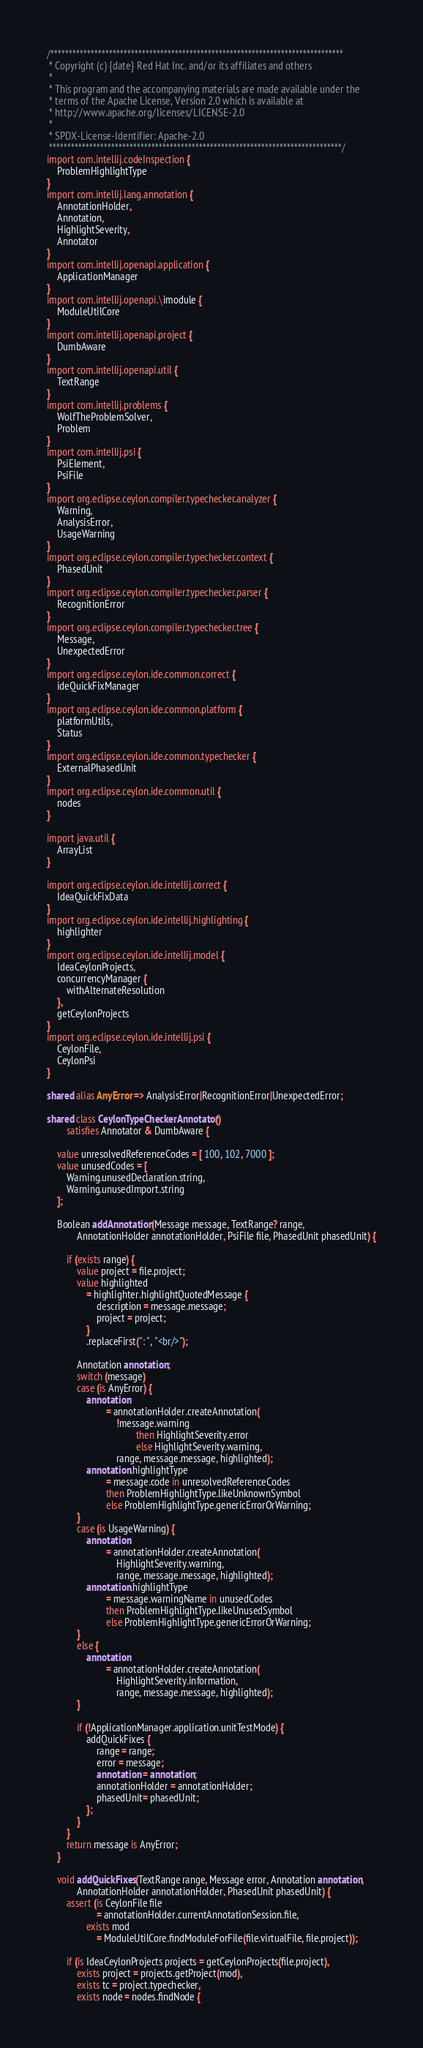Convert code to text. <code><loc_0><loc_0><loc_500><loc_500><_Ceylon_>/********************************************************************************
 * Copyright (c) {date} Red Hat Inc. and/or its affiliates and others
 *
 * This program and the accompanying materials are made available under the 
 * terms of the Apache License, Version 2.0 which is available at
 * http://www.apache.org/licenses/LICENSE-2.0
 *
 * SPDX-License-Identifier: Apache-2.0 
 ********************************************************************************/
import com.intellij.codeInspection {
    ProblemHighlightType
}
import com.intellij.lang.annotation {
    AnnotationHolder,
    Annotation,
    HighlightSeverity,
    Annotator
}
import com.intellij.openapi.application {
    ApplicationManager
}
import com.intellij.openapi.\imodule {
    ModuleUtilCore
}
import com.intellij.openapi.project {
    DumbAware
}
import com.intellij.openapi.util {
    TextRange
}
import com.intellij.problems {
    WolfTheProblemSolver,
    Problem
}
import com.intellij.psi {
    PsiElement,
    PsiFile
}
import org.eclipse.ceylon.compiler.typechecker.analyzer {
    Warning,
    AnalysisError,
    UsageWarning
}
import org.eclipse.ceylon.compiler.typechecker.context {
    PhasedUnit
}
import org.eclipse.ceylon.compiler.typechecker.parser {
    RecognitionError
}
import org.eclipse.ceylon.compiler.typechecker.tree {
    Message,
    UnexpectedError
}
import org.eclipse.ceylon.ide.common.correct {
    ideQuickFixManager
}
import org.eclipse.ceylon.ide.common.platform {
    platformUtils,
    Status
}
import org.eclipse.ceylon.ide.common.typechecker {
    ExternalPhasedUnit
}
import org.eclipse.ceylon.ide.common.util {
    nodes
}

import java.util {
    ArrayList
}

import org.eclipse.ceylon.ide.intellij.correct {
    IdeaQuickFixData
}
import org.eclipse.ceylon.ide.intellij.highlighting {
    highlighter
}
import org.eclipse.ceylon.ide.intellij.model {
    IdeaCeylonProjects,
    concurrencyManager {
        withAlternateResolution
    },
    getCeylonProjects
}
import org.eclipse.ceylon.ide.intellij.psi {
    CeylonFile,
    CeylonPsi
}

shared alias AnyError => AnalysisError|RecognitionError|UnexpectedError;

shared class CeylonTypeCheckerAnnotator() 
        satisfies Annotator & DumbAware {

    value unresolvedReferenceCodes = [ 100, 102, 7000 ];
    value unusedCodes = [
        Warning.unusedDeclaration.string,
        Warning.unusedImport.string
    ];

    Boolean addAnnotation(Message message, TextRange? range,
            AnnotationHolder annotationHolder, PsiFile file, PhasedUnit phasedUnit) {

        if (exists range) {
            value project = file.project;
            value highlighted
                = highlighter.highlightQuotedMessage {
                    description = message.message;
                    project = project;
                }
                .replaceFirst(": ", "<br/>");

            Annotation annotation;
            switch (message)
            case (is AnyError) {
                annotation
                        = annotationHolder.createAnnotation(
                            !message.warning
                                    then HighlightSeverity.error
                                    else HighlightSeverity.warning,
                            range, message.message, highlighted);
                annotation.highlightType
                        = message.code in unresolvedReferenceCodes
                        then ProblemHighlightType.likeUnknownSymbol
                        else ProblemHighlightType.genericErrorOrWarning;
            }
            case (is UsageWarning) {
                annotation
                        = annotationHolder.createAnnotation(
                            HighlightSeverity.warning,
                            range, message.message, highlighted);
                annotation.highlightType
                        = message.warningName in unusedCodes
                        then ProblemHighlightType.likeUnusedSymbol
                        else ProblemHighlightType.genericErrorOrWarning;
            }
            else {
                annotation
                        = annotationHolder.createAnnotation(
                            HighlightSeverity.information,
                            range, message.message, highlighted);
            }

            if (!ApplicationManager.application.unitTestMode) {
                addQuickFixes {
                    range = range;
                    error = message;
                    annotation = annotation;
                    annotationHolder = annotationHolder;
                    phasedUnit= phasedUnit;
                };
            }
        }
        return message is AnyError;
    }

    void addQuickFixes(TextRange range, Message error, Annotation annotation,
            AnnotationHolder annotationHolder, PhasedUnit phasedUnit) {
        assert (is CeylonFile file
                    = annotationHolder.currentAnnotationSession.file,
                exists mod
                    = ModuleUtilCore.findModuleForFile(file.virtualFile, file.project));
        
        if (is IdeaCeylonProjects projects = getCeylonProjects(file.project),
            exists project = projects.getProject(mod),
            exists tc = project.typechecker,
            exists node = nodes.findNode {</code> 